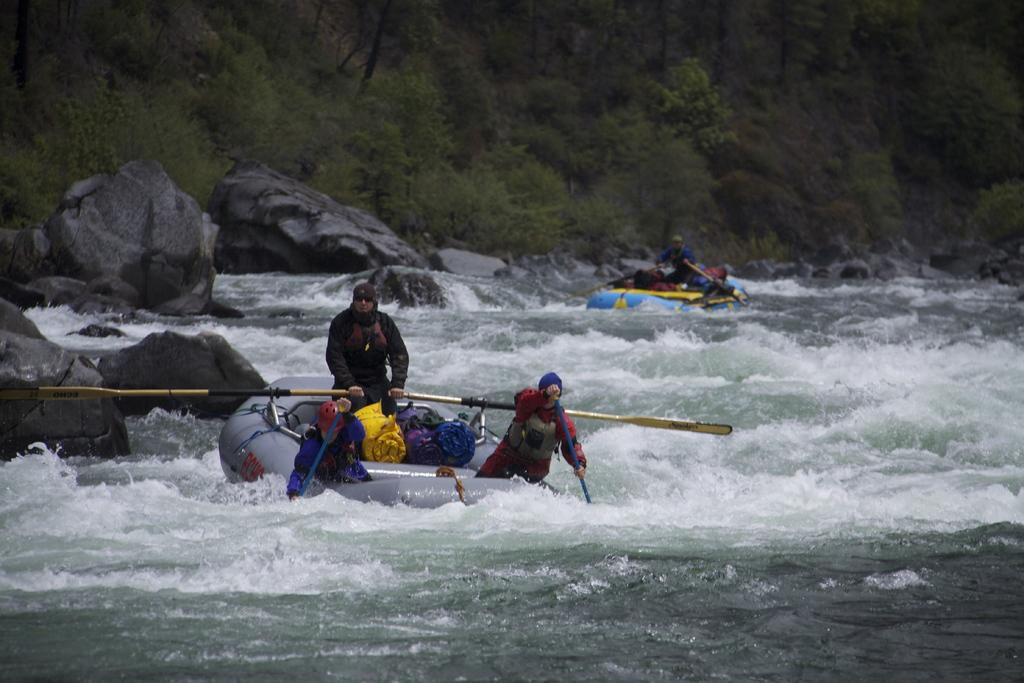How many boats are in the image? There are two boats in the image. Where are the boats located? The boats are on the water. What are the people in the boats doing? The people are holding paddles and using their hands to hold them. What can be seen on the boats besides the people and paddles? There are clothes visible on the boats. What is visible in the background of the image? There are rocks and trees in the background of the image. What type of shoe can be seen on the ear of the person in the image? There is no shoe visible on the ear of the person in the image, as the image does not depict any shoes or ears. 